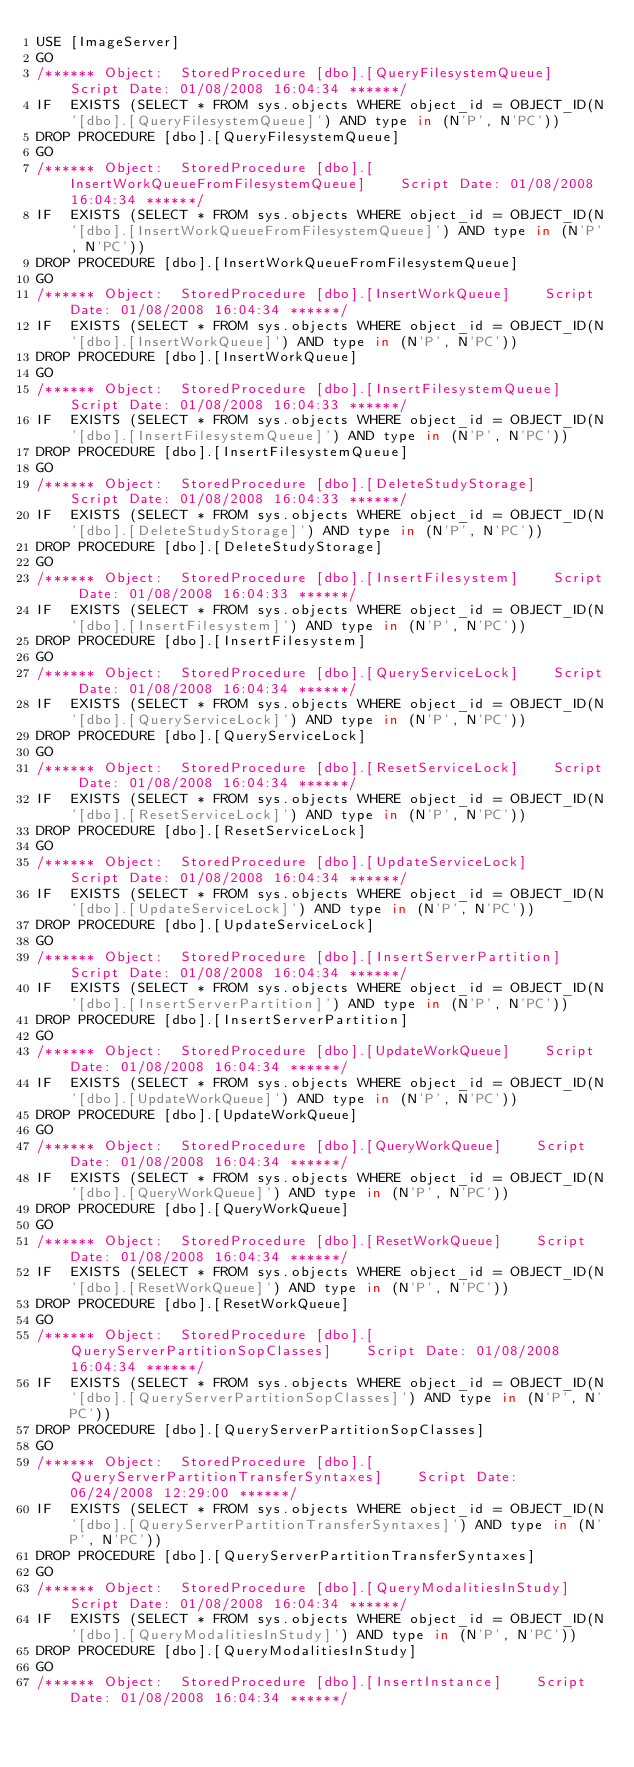Convert code to text. <code><loc_0><loc_0><loc_500><loc_500><_SQL_>USE [ImageServer]
GO
/****** Object:  StoredProcedure [dbo].[QueryFilesystemQueue]    Script Date: 01/08/2008 16:04:34 ******/
IF  EXISTS (SELECT * FROM sys.objects WHERE object_id = OBJECT_ID(N'[dbo].[QueryFilesystemQueue]') AND type in (N'P', N'PC'))
DROP PROCEDURE [dbo].[QueryFilesystemQueue]
GO
/****** Object:  StoredProcedure [dbo].[InsertWorkQueueFromFilesystemQueue]    Script Date: 01/08/2008 16:04:34 ******/
IF  EXISTS (SELECT * FROM sys.objects WHERE object_id = OBJECT_ID(N'[dbo].[InsertWorkQueueFromFilesystemQueue]') AND type in (N'P', N'PC'))
DROP PROCEDURE [dbo].[InsertWorkQueueFromFilesystemQueue]
GO
/****** Object:  StoredProcedure [dbo].[InsertWorkQueue]    Script Date: 01/08/2008 16:04:34 ******/
IF  EXISTS (SELECT * FROM sys.objects WHERE object_id = OBJECT_ID(N'[dbo].[InsertWorkQueue]') AND type in (N'P', N'PC'))
DROP PROCEDURE [dbo].[InsertWorkQueue]
GO
/****** Object:  StoredProcedure [dbo].[InsertFilesystemQueue]    Script Date: 01/08/2008 16:04:33 ******/
IF  EXISTS (SELECT * FROM sys.objects WHERE object_id = OBJECT_ID(N'[dbo].[InsertFilesystemQueue]') AND type in (N'P', N'PC'))
DROP PROCEDURE [dbo].[InsertFilesystemQueue]
GO
/****** Object:  StoredProcedure [dbo].[DeleteStudyStorage]    Script Date: 01/08/2008 16:04:33 ******/
IF  EXISTS (SELECT * FROM sys.objects WHERE object_id = OBJECT_ID(N'[dbo].[DeleteStudyStorage]') AND type in (N'P', N'PC'))
DROP PROCEDURE [dbo].[DeleteStudyStorage]
GO
/****** Object:  StoredProcedure [dbo].[InsertFilesystem]    Script Date: 01/08/2008 16:04:33 ******/
IF  EXISTS (SELECT * FROM sys.objects WHERE object_id = OBJECT_ID(N'[dbo].[InsertFilesystem]') AND type in (N'P', N'PC'))
DROP PROCEDURE [dbo].[InsertFilesystem]
GO
/****** Object:  StoredProcedure [dbo].[QueryServiceLock]    Script Date: 01/08/2008 16:04:34 ******/
IF  EXISTS (SELECT * FROM sys.objects WHERE object_id = OBJECT_ID(N'[dbo].[QueryServiceLock]') AND type in (N'P', N'PC'))
DROP PROCEDURE [dbo].[QueryServiceLock]
GO
/****** Object:  StoredProcedure [dbo].[ResetServiceLock]    Script Date: 01/08/2008 16:04:34 ******/
IF  EXISTS (SELECT * FROM sys.objects WHERE object_id = OBJECT_ID(N'[dbo].[ResetServiceLock]') AND type in (N'P', N'PC'))
DROP PROCEDURE [dbo].[ResetServiceLock]
GO
/****** Object:  StoredProcedure [dbo].[UpdateServiceLock]    Script Date: 01/08/2008 16:04:34 ******/
IF  EXISTS (SELECT * FROM sys.objects WHERE object_id = OBJECT_ID(N'[dbo].[UpdateServiceLock]') AND type in (N'P', N'PC'))
DROP PROCEDURE [dbo].[UpdateServiceLock]
GO
/****** Object:  StoredProcedure [dbo].[InsertServerPartition]    Script Date: 01/08/2008 16:04:34 ******/
IF  EXISTS (SELECT * FROM sys.objects WHERE object_id = OBJECT_ID(N'[dbo].[InsertServerPartition]') AND type in (N'P', N'PC'))
DROP PROCEDURE [dbo].[InsertServerPartition]
GO
/****** Object:  StoredProcedure [dbo].[UpdateWorkQueue]    Script Date: 01/08/2008 16:04:34 ******/
IF  EXISTS (SELECT * FROM sys.objects WHERE object_id = OBJECT_ID(N'[dbo].[UpdateWorkQueue]') AND type in (N'P', N'PC'))
DROP PROCEDURE [dbo].[UpdateWorkQueue]
GO
/****** Object:  StoredProcedure [dbo].[QueryWorkQueue]    Script Date: 01/08/2008 16:04:34 ******/
IF  EXISTS (SELECT * FROM sys.objects WHERE object_id = OBJECT_ID(N'[dbo].[QueryWorkQueue]') AND type in (N'P', N'PC'))
DROP PROCEDURE [dbo].[QueryWorkQueue]
GO
/****** Object:  StoredProcedure [dbo].[ResetWorkQueue]    Script Date: 01/08/2008 16:04:34 ******/
IF  EXISTS (SELECT * FROM sys.objects WHERE object_id = OBJECT_ID(N'[dbo].[ResetWorkQueue]') AND type in (N'P', N'PC'))
DROP PROCEDURE [dbo].[ResetWorkQueue]
GO
/****** Object:  StoredProcedure [dbo].[QueryServerPartitionSopClasses]    Script Date: 01/08/2008 16:04:34 ******/
IF  EXISTS (SELECT * FROM sys.objects WHERE object_id = OBJECT_ID(N'[dbo].[QueryServerPartitionSopClasses]') AND type in (N'P', N'PC'))
DROP PROCEDURE [dbo].[QueryServerPartitionSopClasses]
GO
/****** Object:  StoredProcedure [dbo].[QueryServerPartitionTransferSyntaxes]    Script Date: 06/24/2008 12:29:00 ******/
IF  EXISTS (SELECT * FROM sys.objects WHERE object_id = OBJECT_ID(N'[dbo].[QueryServerPartitionTransferSyntaxes]') AND type in (N'P', N'PC'))
DROP PROCEDURE [dbo].[QueryServerPartitionTransferSyntaxes]
GO
/****** Object:  StoredProcedure [dbo].[QueryModalitiesInStudy]    Script Date: 01/08/2008 16:04:34 ******/
IF  EXISTS (SELECT * FROM sys.objects WHERE object_id = OBJECT_ID(N'[dbo].[QueryModalitiesInStudy]') AND type in (N'P', N'PC'))
DROP PROCEDURE [dbo].[QueryModalitiesInStudy]
GO
/****** Object:  StoredProcedure [dbo].[InsertInstance]    Script Date: 01/08/2008 16:04:34 ******/</code> 